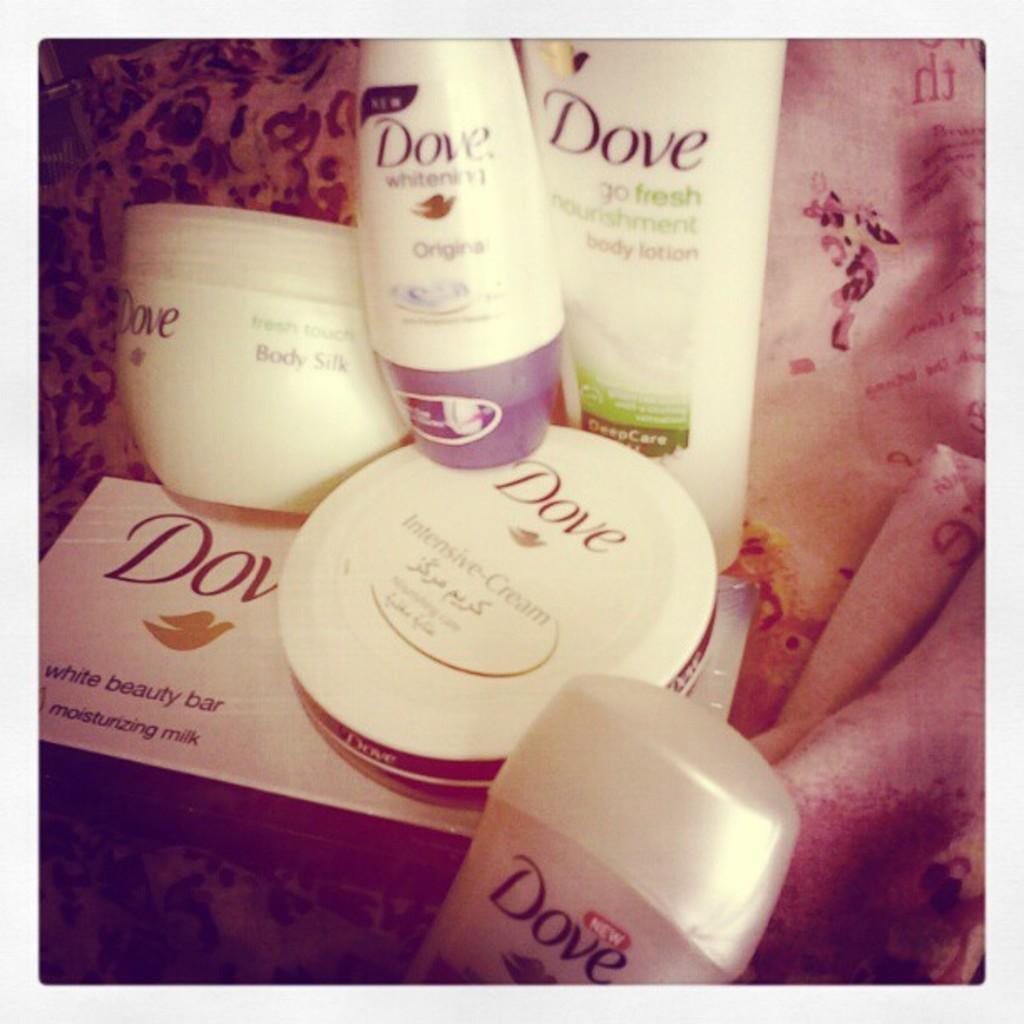What is in the box on the bottom?
Give a very brief answer. White beauty bar. 